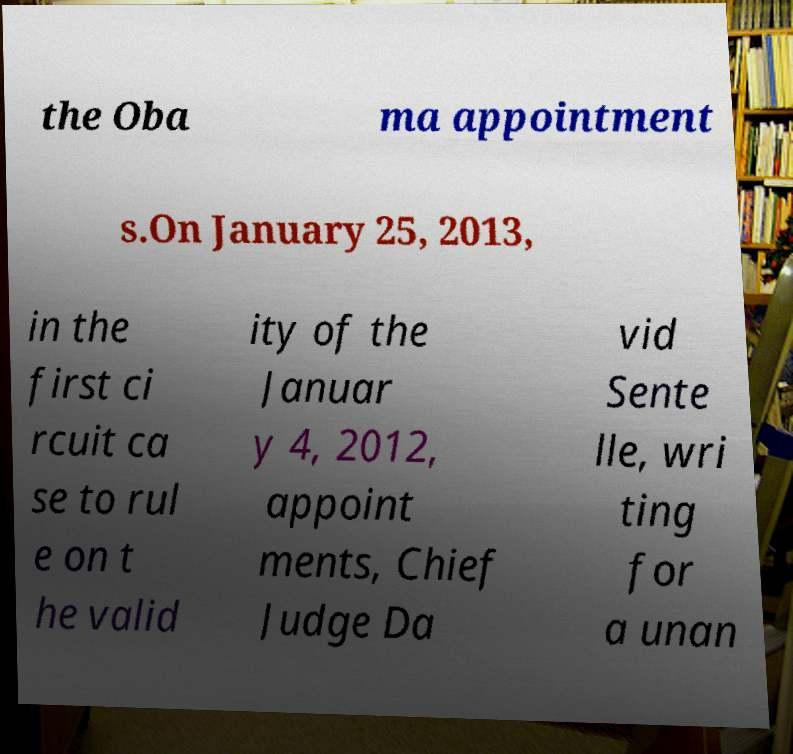What messages or text are displayed in this image? I need them in a readable, typed format. the Oba ma appointment s.On January 25, 2013, in the first ci rcuit ca se to rul e on t he valid ity of the Januar y 4, 2012, appoint ments, Chief Judge Da vid Sente lle, wri ting for a unan 